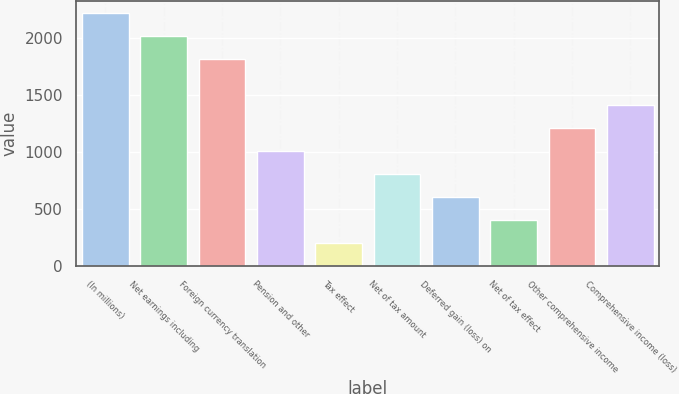Convert chart to OTSL. <chart><loc_0><loc_0><loc_500><loc_500><bar_chart><fcel>(In millions)<fcel>Net earnings including<fcel>Foreign currency translation<fcel>Pension and other<fcel>Tax effect<fcel>Net of tax amount<fcel>Deferred gain (loss) on<fcel>Net of tax effect<fcel>Other comprehensive income<fcel>Comprehensive income (loss)<nl><fcel>2216.1<fcel>2015<fcel>1813.9<fcel>1009.5<fcel>205.1<fcel>808.4<fcel>607.3<fcel>406.2<fcel>1210.6<fcel>1411.7<nl></chart> 